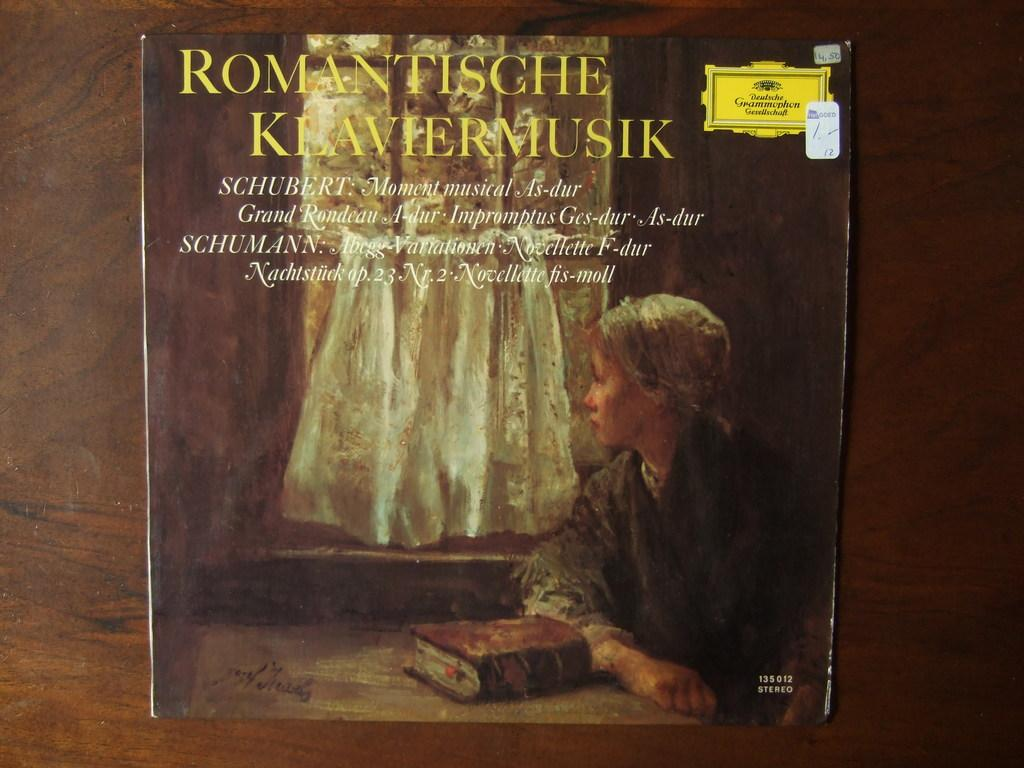<image>
Present a compact description of the photo's key features. A book by Romantische Kravermusik shows a woman staring out the window on the cover 